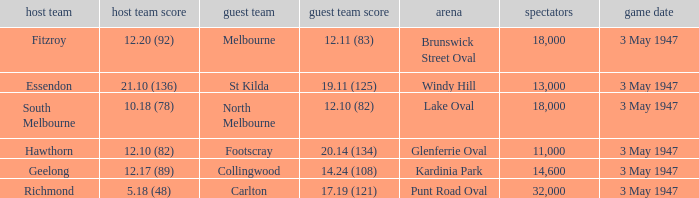Which venue did the away team score 12.10 (82)? Lake Oval. 